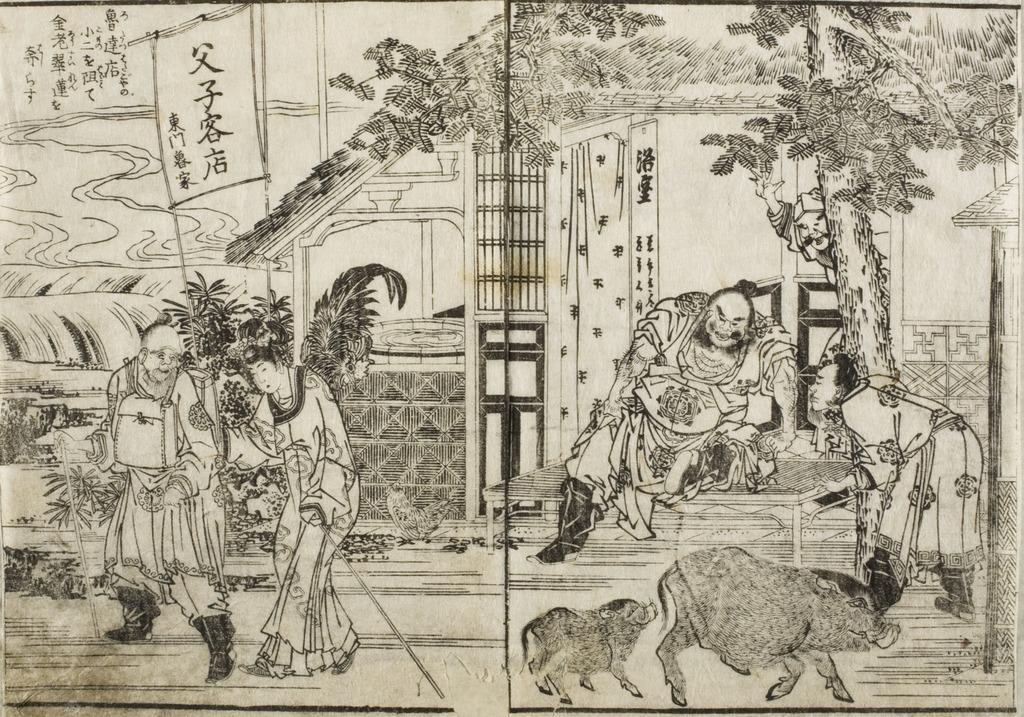Describe this image in one or two sentences. In this image the is an art of few people, animals, trees, plants, house and some text. 